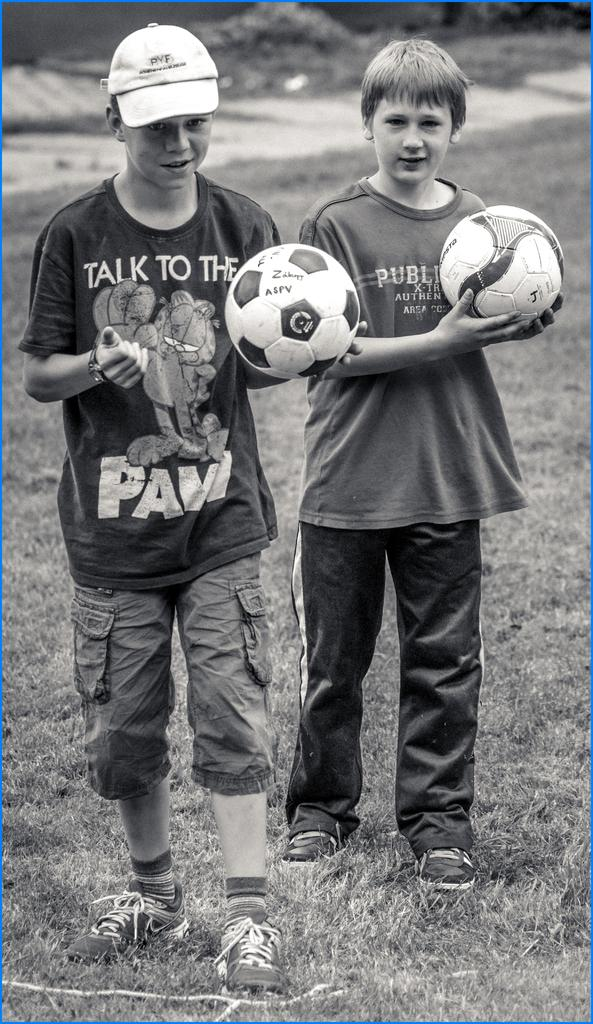How many people are in the image? There are two boys in the image. What is the surface they are standing on? The boys are standing on grass. What are the boys holding in the image? The boys are holding a football. What song are the boys singing in the image? There is no indication in the image that the boys are singing a song. 